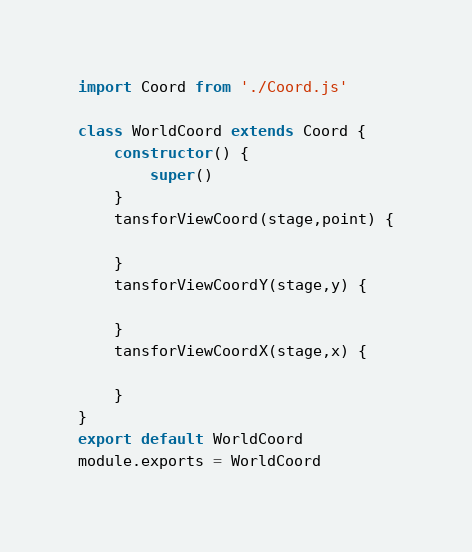Convert code to text. <code><loc_0><loc_0><loc_500><loc_500><_JavaScript_>import Coord from './Coord.js'

class WorldCoord extends Coord {
    constructor() {
        super()
    }
    tansforViewCoord(stage,point) {

    }
    tansforViewCoordY(stage,y) {

    }
    tansforViewCoordX(stage,x) {

    }
}
export default WorldCoord
module.exports = WorldCoord</code> 